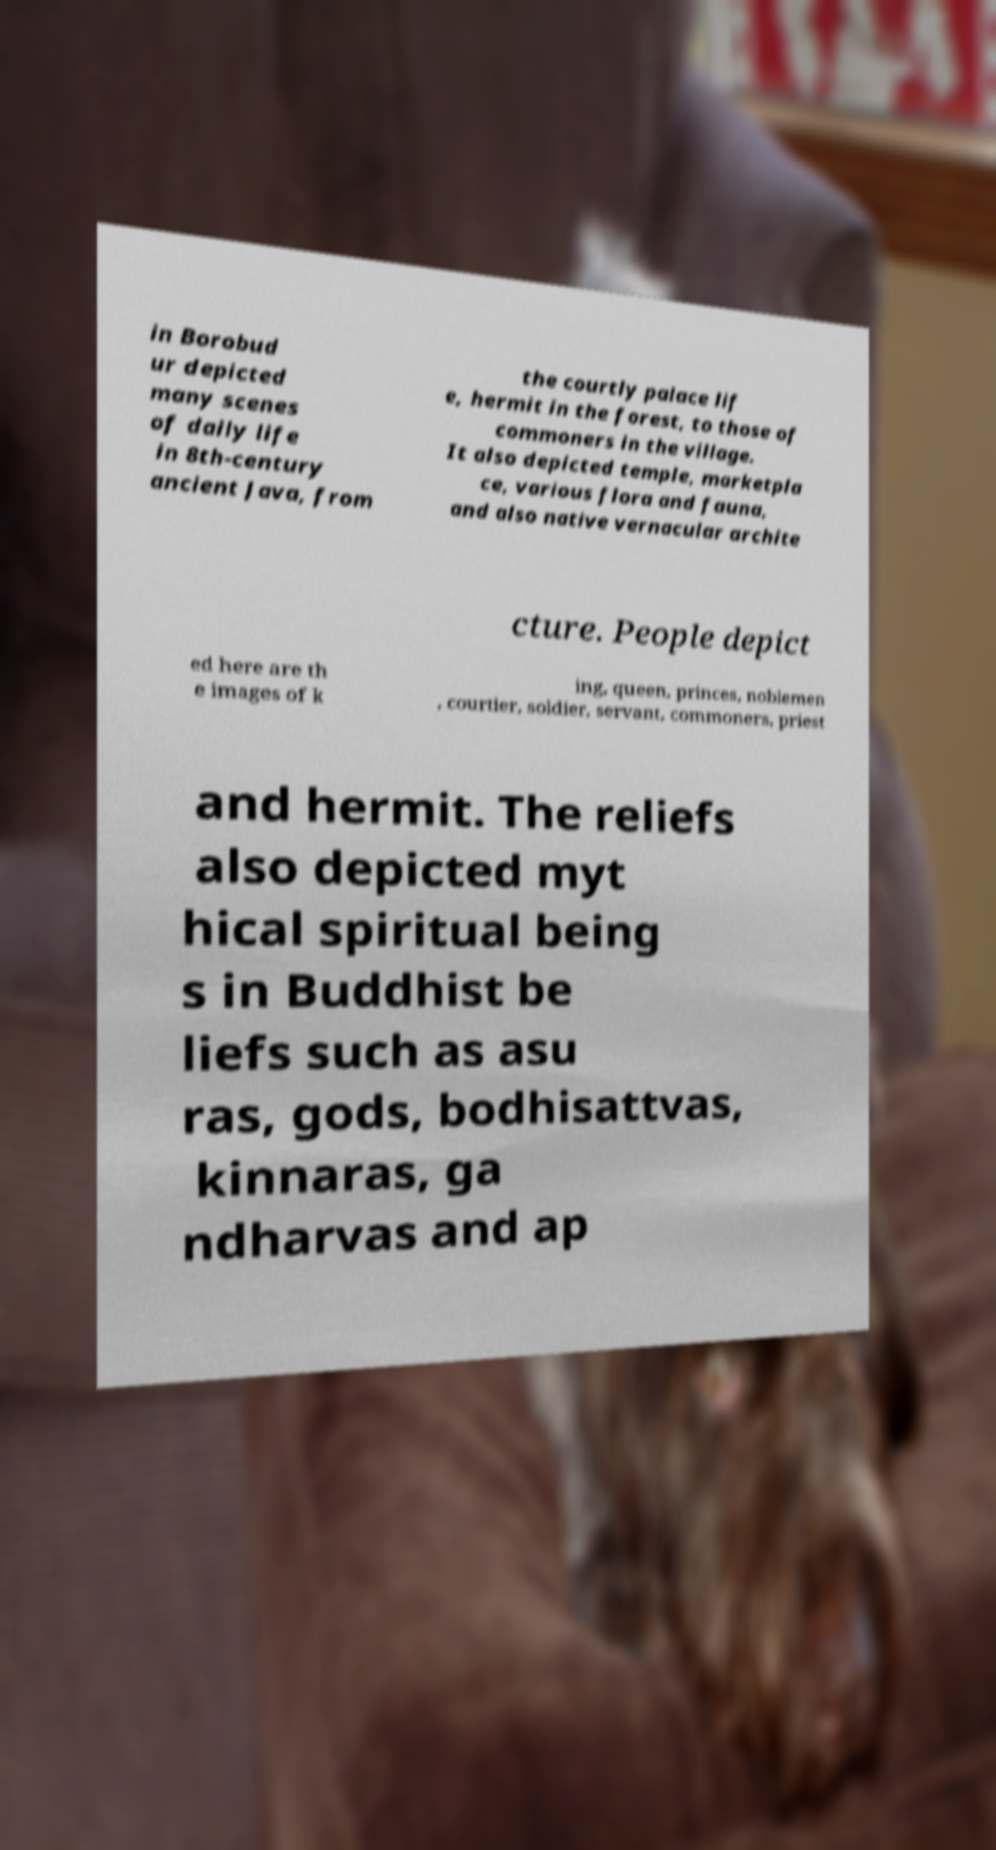Can you read and provide the text displayed in the image?This photo seems to have some interesting text. Can you extract and type it out for me? in Borobud ur depicted many scenes of daily life in 8th-century ancient Java, from the courtly palace lif e, hermit in the forest, to those of commoners in the village. It also depicted temple, marketpla ce, various flora and fauna, and also native vernacular archite cture. People depict ed here are th e images of k ing, queen, princes, noblemen , courtier, soldier, servant, commoners, priest and hermit. The reliefs also depicted myt hical spiritual being s in Buddhist be liefs such as asu ras, gods, bodhisattvas, kinnaras, ga ndharvas and ap 